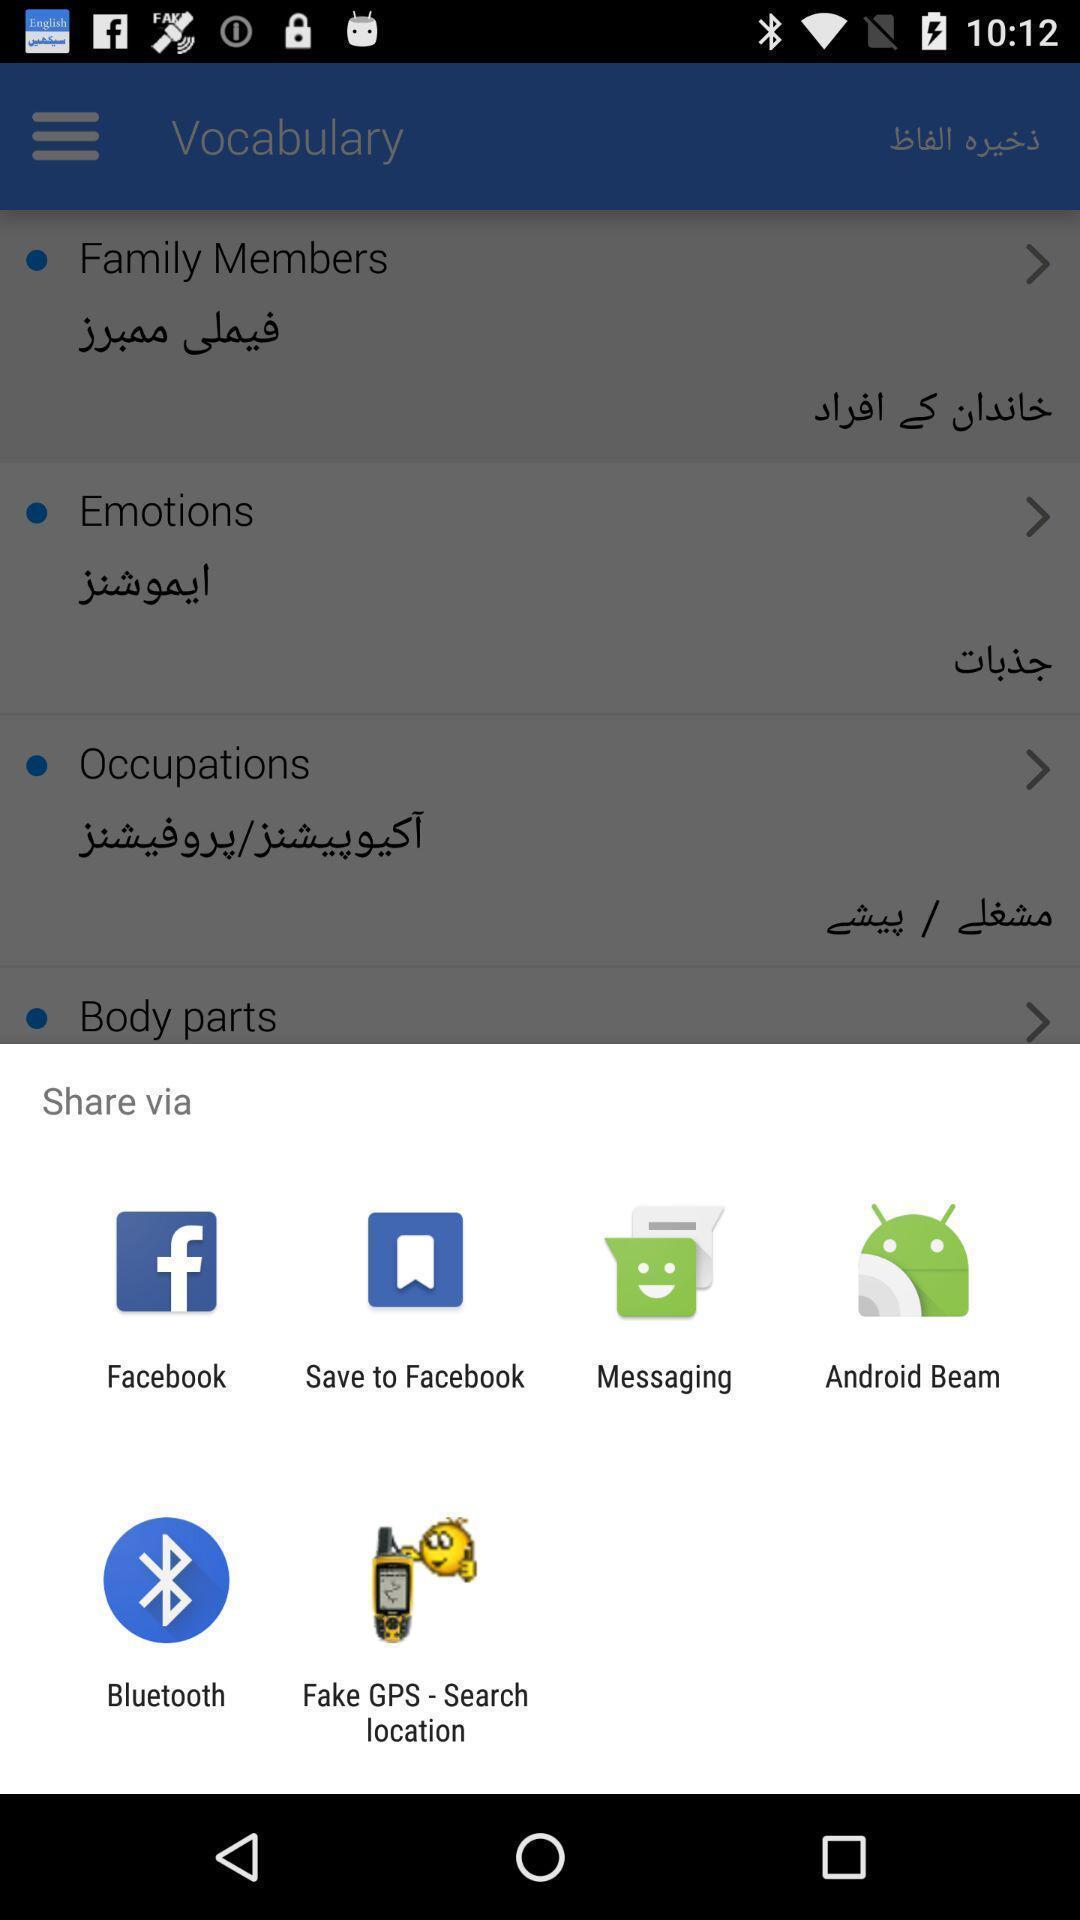Summarize the main components in this picture. Widget displaying multiple data transferring apps. 